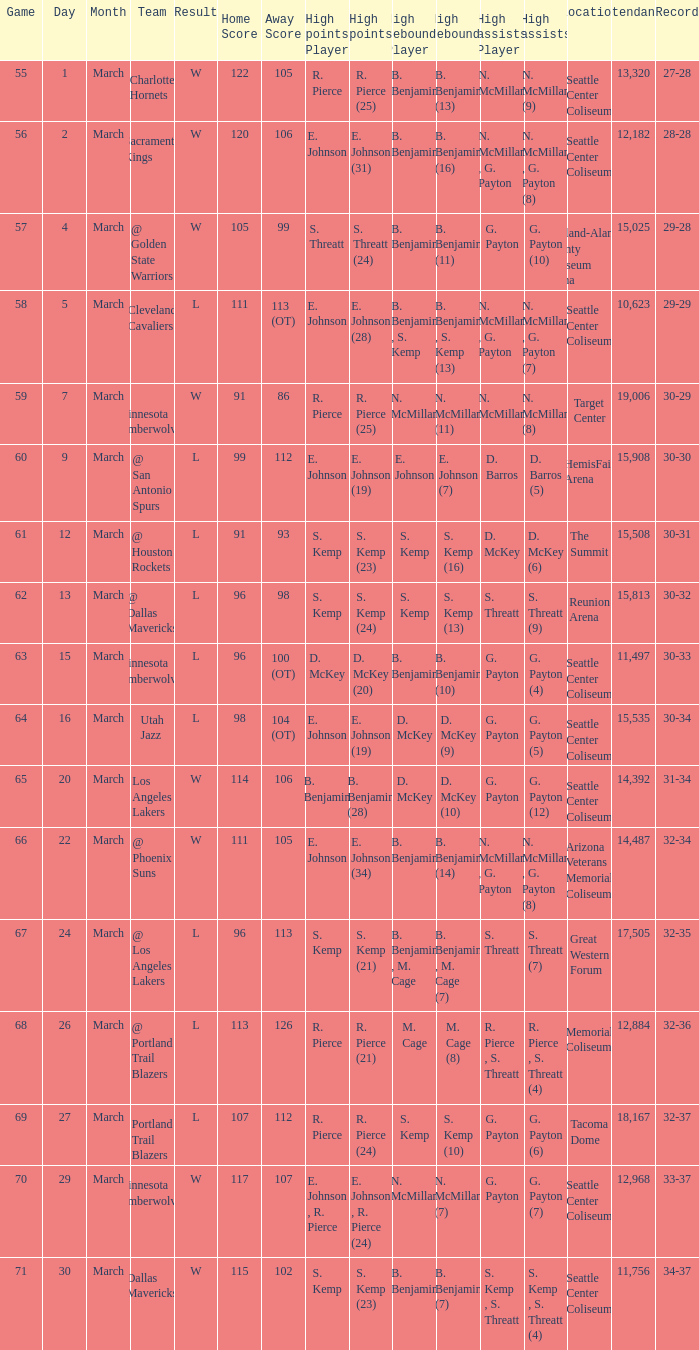Which Game has High assists of s. threatt (9)? 62.0. 